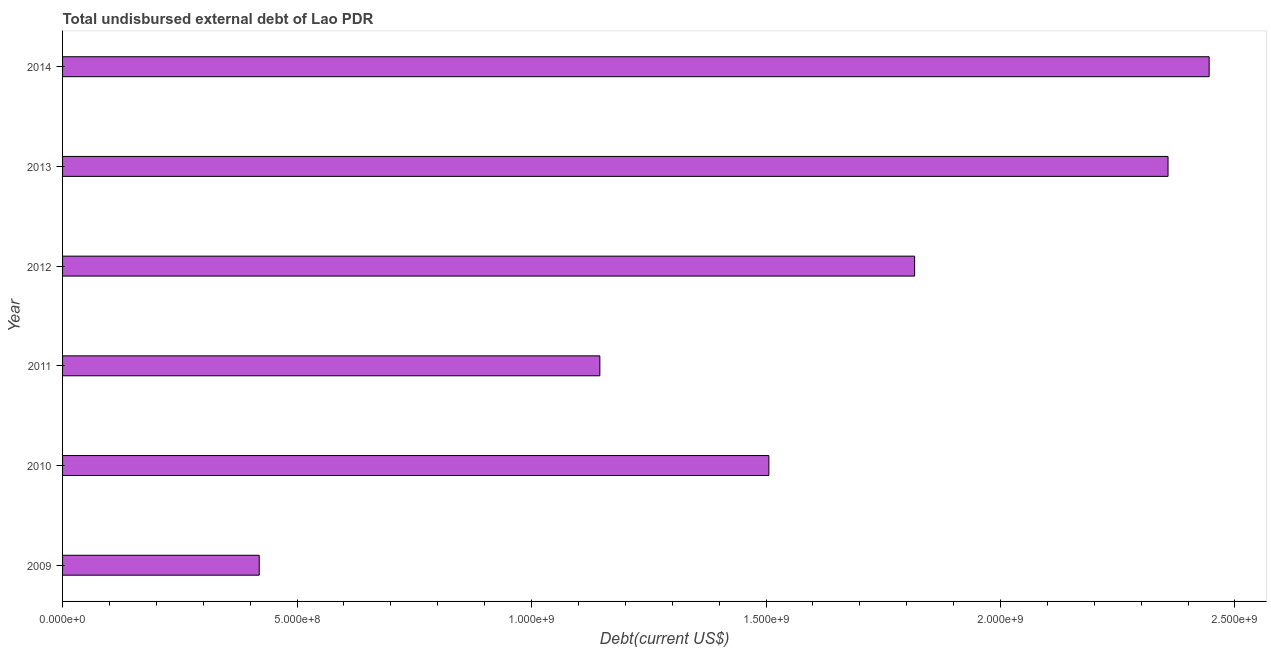Does the graph contain any zero values?
Give a very brief answer. No. What is the title of the graph?
Your answer should be compact. Total undisbursed external debt of Lao PDR. What is the label or title of the X-axis?
Ensure brevity in your answer.  Debt(current US$). What is the label or title of the Y-axis?
Your answer should be compact. Year. What is the total debt in 2009?
Your answer should be very brief. 4.19e+08. Across all years, what is the maximum total debt?
Offer a terse response. 2.44e+09. Across all years, what is the minimum total debt?
Offer a very short reply. 4.19e+08. In which year was the total debt maximum?
Provide a short and direct response. 2014. What is the sum of the total debt?
Your response must be concise. 9.69e+09. What is the difference between the total debt in 2009 and 2014?
Provide a short and direct response. -2.03e+09. What is the average total debt per year?
Your answer should be very brief. 1.62e+09. What is the median total debt?
Keep it short and to the point. 1.66e+09. Do a majority of the years between 2014 and 2012 (inclusive) have total debt greater than 100000000 US$?
Give a very brief answer. Yes. What is the ratio of the total debt in 2010 to that in 2012?
Provide a short and direct response. 0.83. Is the difference between the total debt in 2012 and 2013 greater than the difference between any two years?
Give a very brief answer. No. What is the difference between the highest and the second highest total debt?
Make the answer very short. 8.77e+07. What is the difference between the highest and the lowest total debt?
Your response must be concise. 2.03e+09. Are all the bars in the graph horizontal?
Your response must be concise. Yes. What is the difference between two consecutive major ticks on the X-axis?
Give a very brief answer. 5.00e+08. What is the Debt(current US$) of 2009?
Provide a succinct answer. 4.19e+08. What is the Debt(current US$) in 2010?
Keep it short and to the point. 1.51e+09. What is the Debt(current US$) of 2011?
Ensure brevity in your answer.  1.15e+09. What is the Debt(current US$) in 2012?
Your answer should be very brief. 1.82e+09. What is the Debt(current US$) in 2013?
Offer a terse response. 2.36e+09. What is the Debt(current US$) in 2014?
Offer a very short reply. 2.44e+09. What is the difference between the Debt(current US$) in 2009 and 2010?
Make the answer very short. -1.09e+09. What is the difference between the Debt(current US$) in 2009 and 2011?
Offer a very short reply. -7.26e+08. What is the difference between the Debt(current US$) in 2009 and 2012?
Make the answer very short. -1.40e+09. What is the difference between the Debt(current US$) in 2009 and 2013?
Your answer should be compact. -1.94e+09. What is the difference between the Debt(current US$) in 2009 and 2014?
Your response must be concise. -2.03e+09. What is the difference between the Debt(current US$) in 2010 and 2011?
Give a very brief answer. 3.60e+08. What is the difference between the Debt(current US$) in 2010 and 2012?
Your answer should be very brief. -3.11e+08. What is the difference between the Debt(current US$) in 2010 and 2013?
Make the answer very short. -8.51e+08. What is the difference between the Debt(current US$) in 2010 and 2014?
Provide a succinct answer. -9.39e+08. What is the difference between the Debt(current US$) in 2011 and 2012?
Offer a very short reply. -6.71e+08. What is the difference between the Debt(current US$) in 2011 and 2013?
Your answer should be very brief. -1.21e+09. What is the difference between the Debt(current US$) in 2011 and 2014?
Your answer should be compact. -1.30e+09. What is the difference between the Debt(current US$) in 2012 and 2013?
Ensure brevity in your answer.  -5.40e+08. What is the difference between the Debt(current US$) in 2012 and 2014?
Offer a very short reply. -6.28e+08. What is the difference between the Debt(current US$) in 2013 and 2014?
Offer a very short reply. -8.77e+07. What is the ratio of the Debt(current US$) in 2009 to that in 2010?
Offer a terse response. 0.28. What is the ratio of the Debt(current US$) in 2009 to that in 2011?
Provide a succinct answer. 0.37. What is the ratio of the Debt(current US$) in 2009 to that in 2012?
Your answer should be very brief. 0.23. What is the ratio of the Debt(current US$) in 2009 to that in 2013?
Offer a terse response. 0.18. What is the ratio of the Debt(current US$) in 2009 to that in 2014?
Provide a short and direct response. 0.17. What is the ratio of the Debt(current US$) in 2010 to that in 2011?
Give a very brief answer. 1.31. What is the ratio of the Debt(current US$) in 2010 to that in 2012?
Ensure brevity in your answer.  0.83. What is the ratio of the Debt(current US$) in 2010 to that in 2013?
Make the answer very short. 0.64. What is the ratio of the Debt(current US$) in 2010 to that in 2014?
Offer a terse response. 0.62. What is the ratio of the Debt(current US$) in 2011 to that in 2012?
Your response must be concise. 0.63. What is the ratio of the Debt(current US$) in 2011 to that in 2013?
Keep it short and to the point. 0.49. What is the ratio of the Debt(current US$) in 2011 to that in 2014?
Ensure brevity in your answer.  0.47. What is the ratio of the Debt(current US$) in 2012 to that in 2013?
Keep it short and to the point. 0.77. What is the ratio of the Debt(current US$) in 2012 to that in 2014?
Ensure brevity in your answer.  0.74. What is the ratio of the Debt(current US$) in 2013 to that in 2014?
Offer a very short reply. 0.96. 